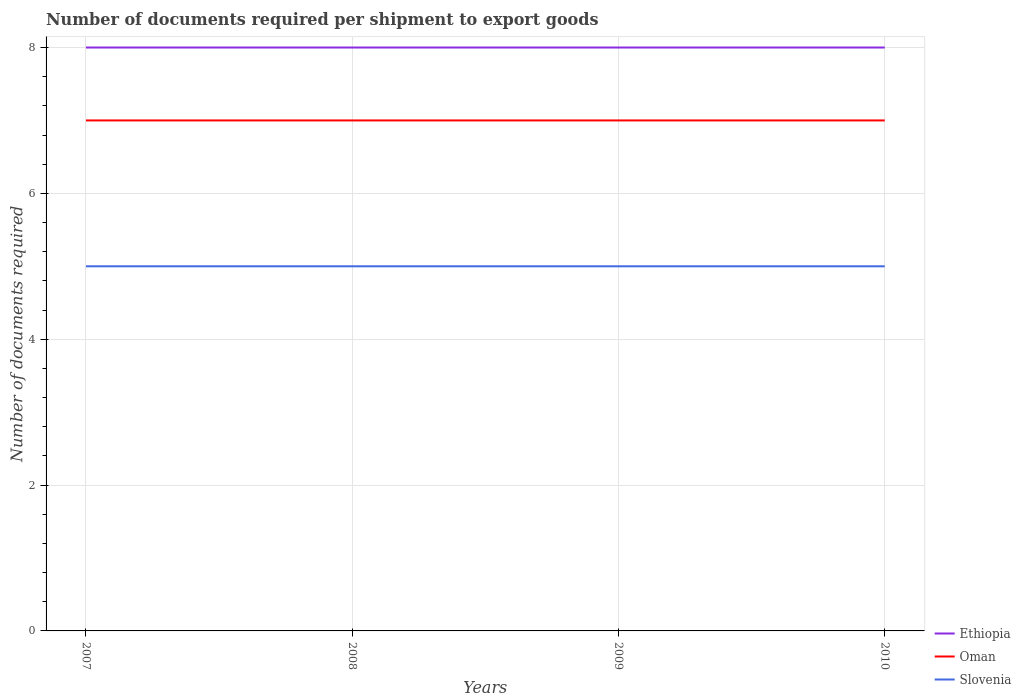How many different coloured lines are there?
Keep it short and to the point. 3. Does the line corresponding to Oman intersect with the line corresponding to Ethiopia?
Give a very brief answer. No. Is the number of lines equal to the number of legend labels?
Give a very brief answer. Yes. Across all years, what is the maximum number of documents required per shipment to export goods in Ethiopia?
Your answer should be compact. 8. What is the total number of documents required per shipment to export goods in Slovenia in the graph?
Provide a succinct answer. 0. What is the difference between the highest and the second highest number of documents required per shipment to export goods in Oman?
Offer a terse response. 0. What is the difference between the highest and the lowest number of documents required per shipment to export goods in Oman?
Your answer should be very brief. 0. How many years are there in the graph?
Offer a very short reply. 4. Does the graph contain any zero values?
Provide a succinct answer. No. How many legend labels are there?
Ensure brevity in your answer.  3. What is the title of the graph?
Make the answer very short. Number of documents required per shipment to export goods. Does "Oman" appear as one of the legend labels in the graph?
Offer a very short reply. Yes. What is the label or title of the X-axis?
Provide a succinct answer. Years. What is the label or title of the Y-axis?
Offer a terse response. Number of documents required. What is the Number of documents required of Ethiopia in 2007?
Offer a terse response. 8. What is the Number of documents required in Oman in 2007?
Your answer should be compact. 7. What is the Number of documents required of Slovenia in 2007?
Offer a very short reply. 5. What is the Number of documents required in Ethiopia in 2008?
Ensure brevity in your answer.  8. What is the Number of documents required in Slovenia in 2008?
Offer a very short reply. 5. What is the Number of documents required in Oman in 2009?
Offer a terse response. 7. What is the Number of documents required of Slovenia in 2009?
Keep it short and to the point. 5. What is the Number of documents required of Ethiopia in 2010?
Offer a terse response. 8. What is the Number of documents required in Oman in 2010?
Your answer should be very brief. 7. What is the Number of documents required in Slovenia in 2010?
Give a very brief answer. 5. Across all years, what is the maximum Number of documents required in Ethiopia?
Your answer should be very brief. 8. Across all years, what is the maximum Number of documents required in Oman?
Your answer should be very brief. 7. Across all years, what is the maximum Number of documents required of Slovenia?
Make the answer very short. 5. Across all years, what is the minimum Number of documents required in Ethiopia?
Give a very brief answer. 8. Across all years, what is the minimum Number of documents required of Oman?
Provide a short and direct response. 7. What is the total Number of documents required of Ethiopia in the graph?
Make the answer very short. 32. What is the total Number of documents required in Oman in the graph?
Your response must be concise. 28. What is the difference between the Number of documents required of Ethiopia in 2007 and that in 2008?
Your response must be concise. 0. What is the difference between the Number of documents required of Oman in 2007 and that in 2008?
Your response must be concise. 0. What is the difference between the Number of documents required of Slovenia in 2007 and that in 2008?
Your response must be concise. 0. What is the difference between the Number of documents required in Ethiopia in 2007 and that in 2009?
Provide a short and direct response. 0. What is the difference between the Number of documents required in Ethiopia in 2007 and that in 2010?
Offer a terse response. 0. What is the difference between the Number of documents required in Oman in 2007 and that in 2010?
Ensure brevity in your answer.  0. What is the difference between the Number of documents required in Oman in 2008 and that in 2009?
Offer a very short reply. 0. What is the difference between the Number of documents required of Slovenia in 2008 and that in 2010?
Give a very brief answer. 0. What is the difference between the Number of documents required of Ethiopia in 2009 and that in 2010?
Offer a very short reply. 0. What is the difference between the Number of documents required of Oman in 2009 and that in 2010?
Make the answer very short. 0. What is the difference between the Number of documents required in Slovenia in 2009 and that in 2010?
Ensure brevity in your answer.  0. What is the difference between the Number of documents required of Ethiopia in 2007 and the Number of documents required of Oman in 2008?
Ensure brevity in your answer.  1. What is the difference between the Number of documents required of Ethiopia in 2007 and the Number of documents required of Slovenia in 2008?
Your answer should be compact. 3. What is the difference between the Number of documents required of Oman in 2007 and the Number of documents required of Slovenia in 2008?
Give a very brief answer. 2. What is the difference between the Number of documents required of Ethiopia in 2007 and the Number of documents required of Oman in 2009?
Keep it short and to the point. 1. What is the difference between the Number of documents required in Ethiopia in 2007 and the Number of documents required in Oman in 2010?
Your response must be concise. 1. What is the difference between the Number of documents required in Ethiopia in 2007 and the Number of documents required in Slovenia in 2010?
Offer a terse response. 3. What is the difference between the Number of documents required of Oman in 2007 and the Number of documents required of Slovenia in 2010?
Your answer should be compact. 2. What is the difference between the Number of documents required of Ethiopia in 2008 and the Number of documents required of Slovenia in 2009?
Your answer should be very brief. 3. What is the difference between the Number of documents required in Ethiopia in 2008 and the Number of documents required in Oman in 2010?
Offer a very short reply. 1. What is the difference between the Number of documents required of Oman in 2008 and the Number of documents required of Slovenia in 2010?
Give a very brief answer. 2. What is the difference between the Number of documents required in Ethiopia in 2009 and the Number of documents required in Oman in 2010?
Keep it short and to the point. 1. What is the average Number of documents required of Oman per year?
Give a very brief answer. 7. What is the average Number of documents required in Slovenia per year?
Keep it short and to the point. 5. In the year 2007, what is the difference between the Number of documents required of Ethiopia and Number of documents required of Slovenia?
Give a very brief answer. 3. In the year 2008, what is the difference between the Number of documents required in Oman and Number of documents required in Slovenia?
Your answer should be compact. 2. In the year 2009, what is the difference between the Number of documents required of Ethiopia and Number of documents required of Oman?
Make the answer very short. 1. In the year 2009, what is the difference between the Number of documents required in Oman and Number of documents required in Slovenia?
Offer a terse response. 2. In the year 2010, what is the difference between the Number of documents required of Ethiopia and Number of documents required of Oman?
Provide a succinct answer. 1. In the year 2010, what is the difference between the Number of documents required of Ethiopia and Number of documents required of Slovenia?
Your answer should be compact. 3. What is the ratio of the Number of documents required in Oman in 2007 to that in 2009?
Offer a terse response. 1. What is the ratio of the Number of documents required of Slovenia in 2007 to that in 2009?
Offer a terse response. 1. What is the ratio of the Number of documents required of Ethiopia in 2007 to that in 2010?
Provide a succinct answer. 1. What is the ratio of the Number of documents required in Oman in 2007 to that in 2010?
Your answer should be compact. 1. What is the ratio of the Number of documents required of Oman in 2008 to that in 2009?
Provide a succinct answer. 1. What is the ratio of the Number of documents required in Ethiopia in 2008 to that in 2010?
Your response must be concise. 1. What is the difference between the highest and the second highest Number of documents required in Slovenia?
Make the answer very short. 0. What is the difference between the highest and the lowest Number of documents required in Ethiopia?
Your answer should be very brief. 0. What is the difference between the highest and the lowest Number of documents required of Slovenia?
Offer a terse response. 0. 